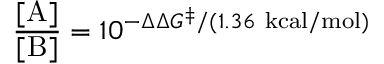<formula> <loc_0><loc_0><loc_500><loc_500>{ \frac { [ A ] } { [ B ] } } = 1 0 ^ { - \Delta \Delta G ^ { \ddagger } / ( 1 . 3 6 \ k c a l / m o l ) }</formula> 